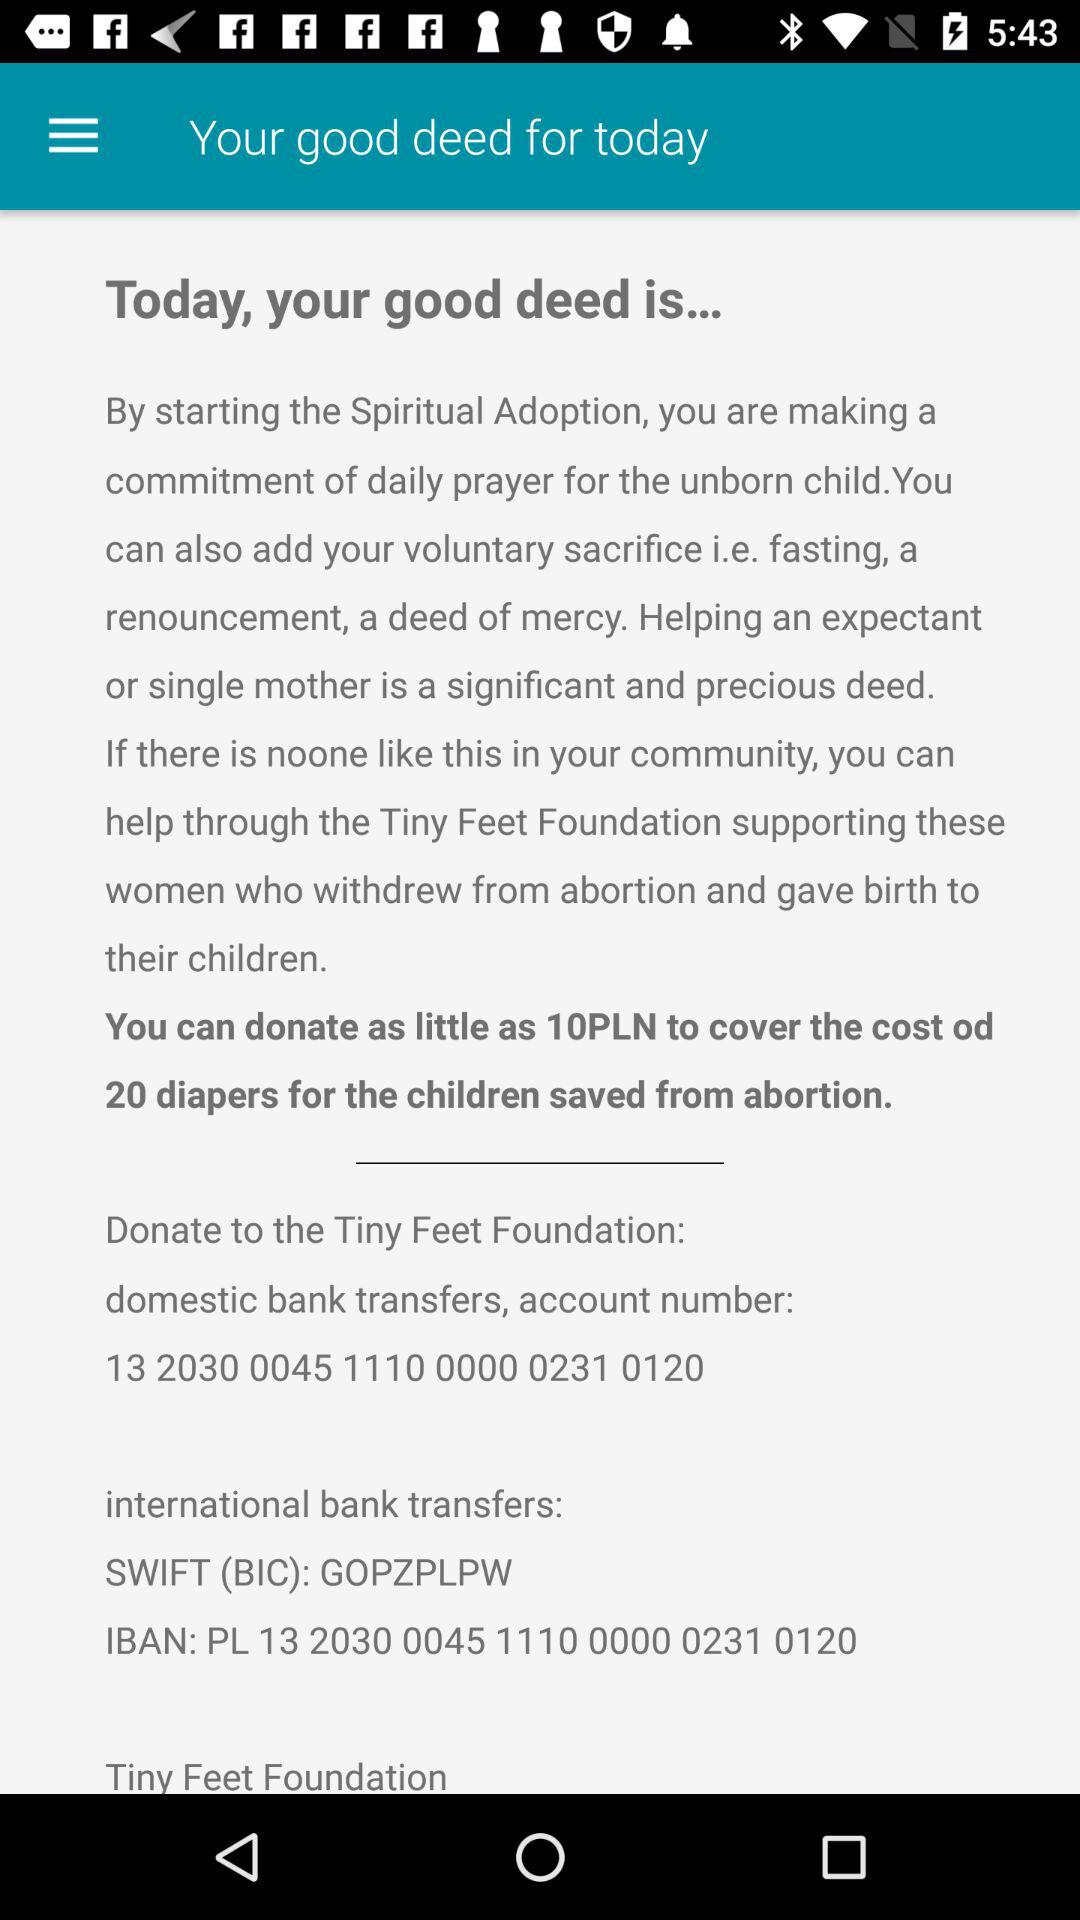What is the SWIFT(BIC) number? The Swift (BIC) number is "GOPZPLPW". 